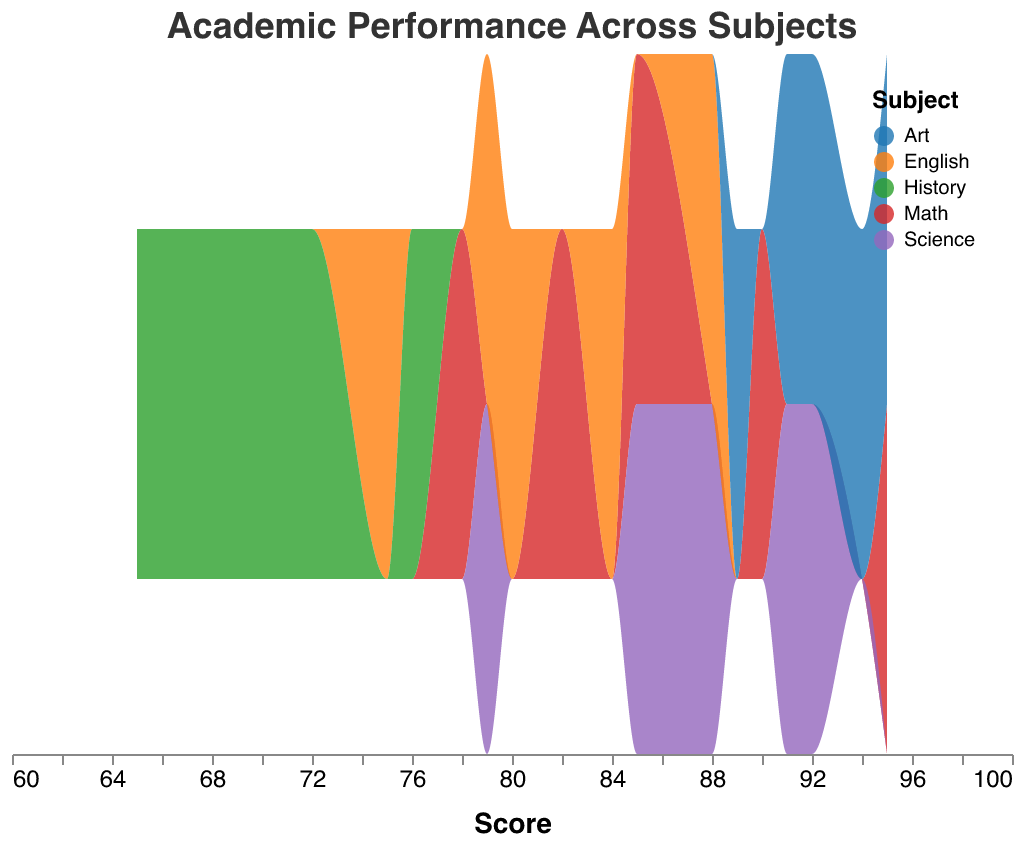What is the title of the plot? The title of the plot is displayed at the top and it says "Academic Performance Across Subjects".
Answer: Academic Performance Across Subjects How many unique subjects are represented in the plot? By looking at the color legend, there are five colors, each representing a different subject: Math, Science, English, History, and Art.
Answer: 5 What score range do most students fall into for Math? By observing the density peaks for Math in the score axis, the highest concentration appears around 78 to 95.
Answer: 78 to 95 Which subject has the highest density peak? Among all subjects, the Art subject reaches the highest density peak as indicated by the thickest area within the range of scores.
Answer: Art How do the scores in History compare to those in Math? The scores in History are generally lower and have a lower density peak compared to those in Math. Math scores range from 78 to 95, while History scores range from 65 to 76.
Answer: History scores are lower Are there any subjects where the student scores are more closely clustered together? By looking at the spread of the density plots, Science scores appear more narrowly clustered compared to other subjects with scores tightly packed between 79 and 92.
Answer: Science Which subject has the widest range of scores? Art has the widest range from 89 to 95, indicating more variation in student scores.
Answer: Art Describe the score distribution for English. The English scores are spread over a range from 75 to 88, with two notable peaks around 79 and 84.
Answer: Score range: 75 to 88, peaks at 79 and 84 In which subject did students achieve the lowest scores? History has the lowest scores, with values ranging from 65 to 76.
Answer: History How do the top scores in Science and English compare? Science top scores are higher, reaching 92, compared to English’s top score of 88.
Answer: Science scores are higher 